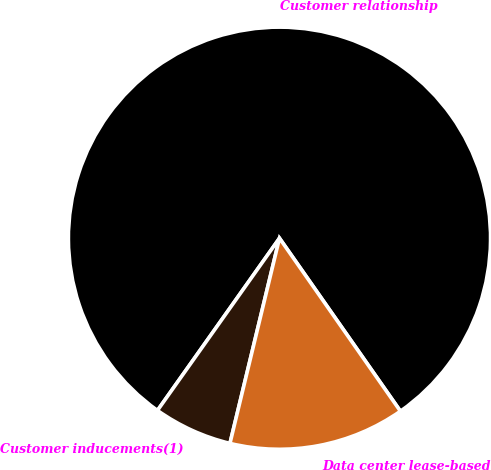Convert chart to OTSL. <chart><loc_0><loc_0><loc_500><loc_500><pie_chart><fcel>Customer relationship<fcel>Customer inducements(1)<fcel>Data center lease-based<nl><fcel>80.48%<fcel>6.04%<fcel>13.48%<nl></chart> 